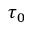<formula> <loc_0><loc_0><loc_500><loc_500>\tau _ { 0 }</formula> 